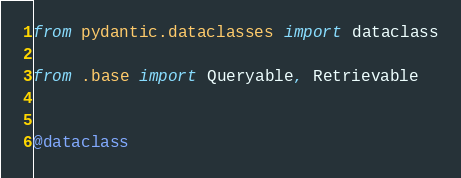Convert code to text. <code><loc_0><loc_0><loc_500><loc_500><_Python_>from pydantic.dataclasses import dataclass

from .base import Queryable, Retrievable


@dataclass</code> 